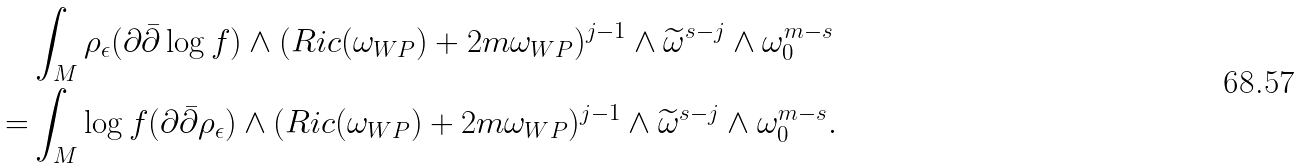<formula> <loc_0><loc_0><loc_500><loc_500>& \int _ { M } \rho _ { \epsilon } ( \partial \bar { \partial } \log f ) \wedge ( R i c ( \omega _ { W P } ) + 2 m \omega _ { W P } ) ^ { j - 1 } \wedge \widetilde { \omega } ^ { s - j } \wedge \omega _ { 0 } ^ { m - s } \\ = & \int _ { M } \log f ( \partial \bar { \partial } \rho _ { \epsilon } ) \wedge ( R i c ( \omega _ { W P } ) + 2 m \omega _ { W P } ) ^ { j - 1 } \wedge \widetilde { \omega } ^ { s - j } \wedge \omega _ { 0 } ^ { m - s } .</formula> 